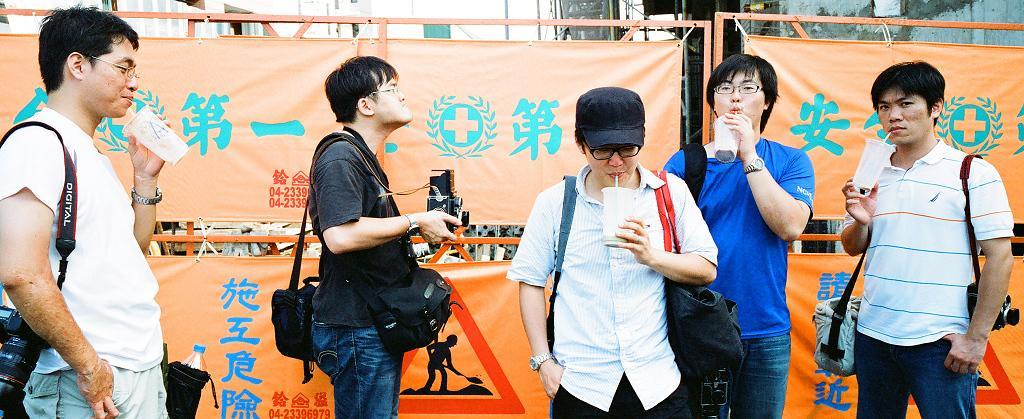How would you summarize this image in a sentence or two? In this image there are a few people standing and holding their bags on their shoulder and they are holding drinks in their hands, one of them is holding a camera in his hand, behind them there are banners. In the background there are buildings. 